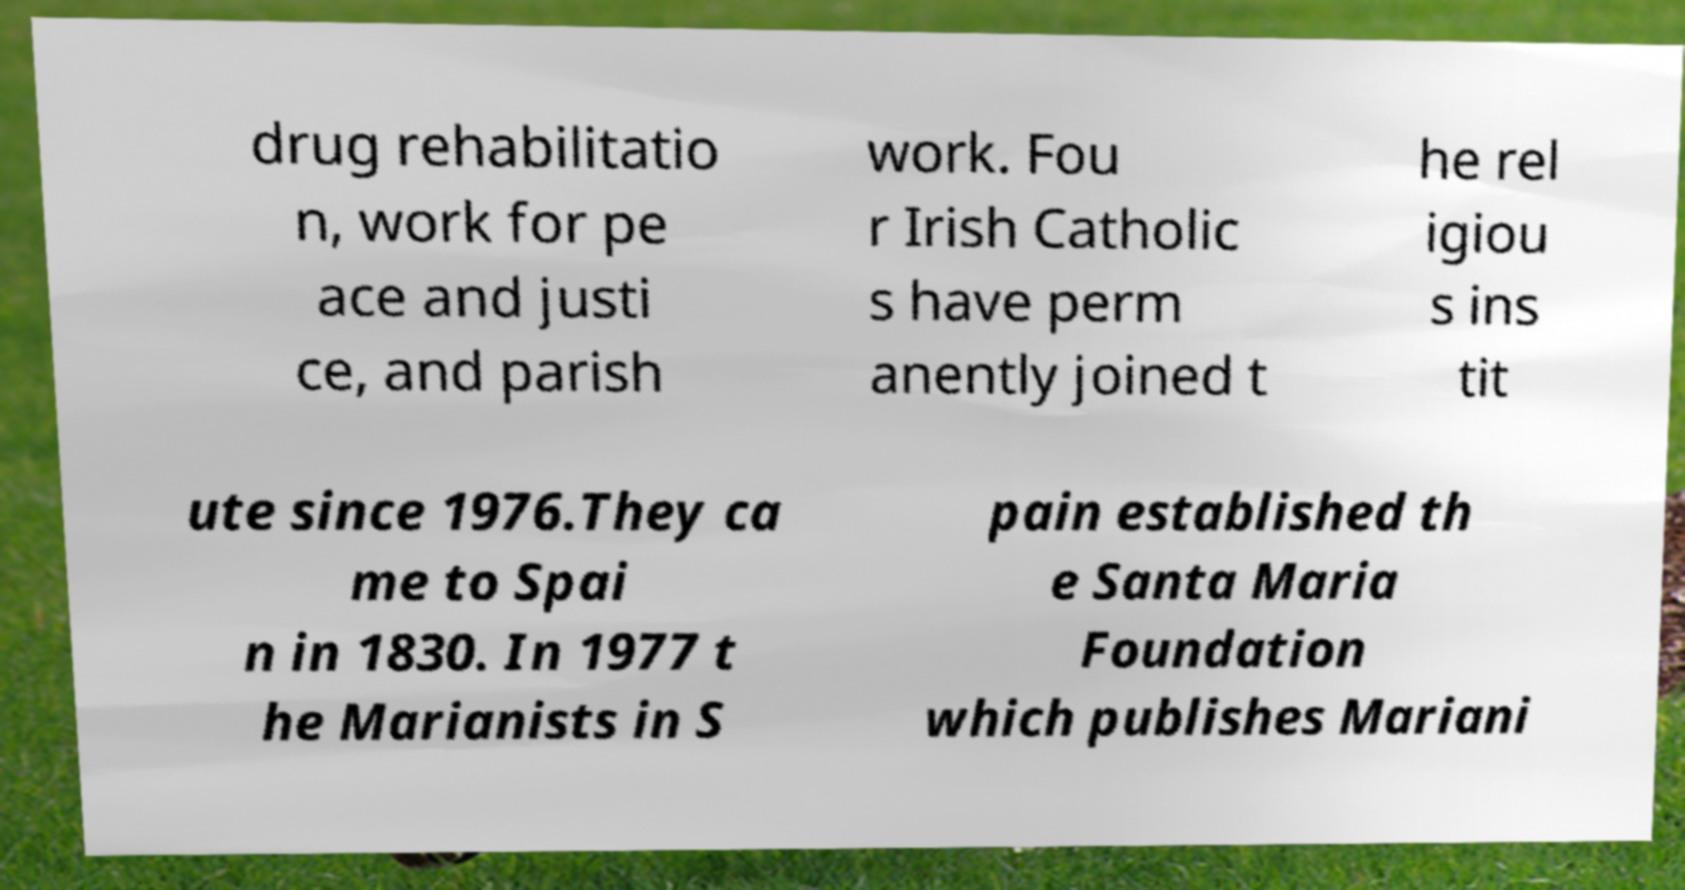Can you read and provide the text displayed in the image?This photo seems to have some interesting text. Can you extract and type it out for me? drug rehabilitatio n, work for pe ace and justi ce, and parish work. Fou r Irish Catholic s have perm anently joined t he rel igiou s ins tit ute since 1976.They ca me to Spai n in 1830. In 1977 t he Marianists in S pain established th e Santa Maria Foundation which publishes Mariani 